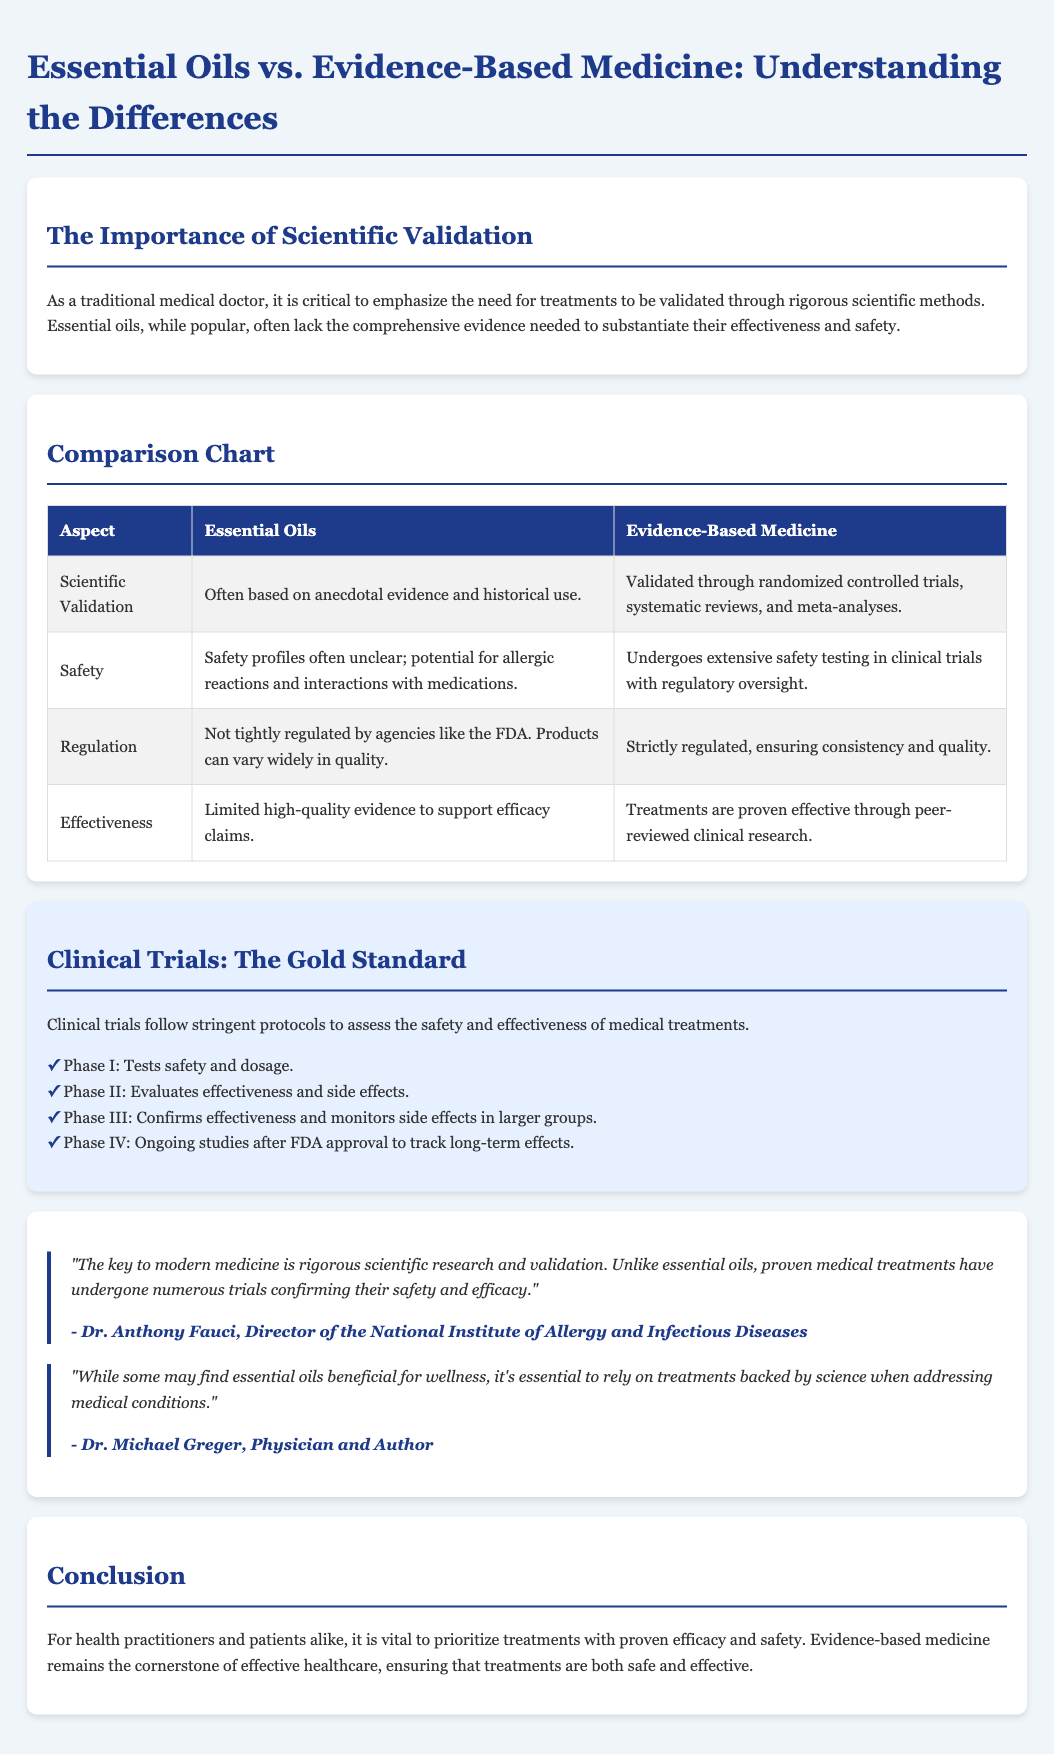What is the title of the flyer? The title of the flyer is provided at the top of the document, stating the main topic of discussion.
Answer: Essential Oils vs. Evidence-Based Medicine: Understanding the Differences What does Phase I of clinical trials test? The document outlines the phases of clinical trials, with Phase I focusing specifically on one aspect.
Answer: Tests safety and dosage Who is quoted regarding the importance of scientific research in medicine? The flyer includes quotes from recognized medical professionals, and one is specifically mentioned.
Answer: Dr. Anthony Fauci In what area do essential oils often lack validation? There is a specific aspect mentioned in the effectiveness and safety of essential oils in relation to scientific validation.
Answer: Scientific Validation What color is used for the header of the comparison chart? The document describes the appearance of the comparison chart headers, specifying their color.
Answer: White What is one potential issue with essential oils mentioned in the flyer? The flyer lists concerns associated with essential oils, which include various risks.
Answer: Allergic reactions What type of evidence does evidence-based medicine rely on? The document describes the methodology behind evidence-based medicine, specifically the nature of its foundation.
Answer: Randomized controlled trials How does essential oils regulation compare to evidence-based medicine? The document explicitly compares regulatory practices between the two health approaches.
Answer: Not tightly regulated 